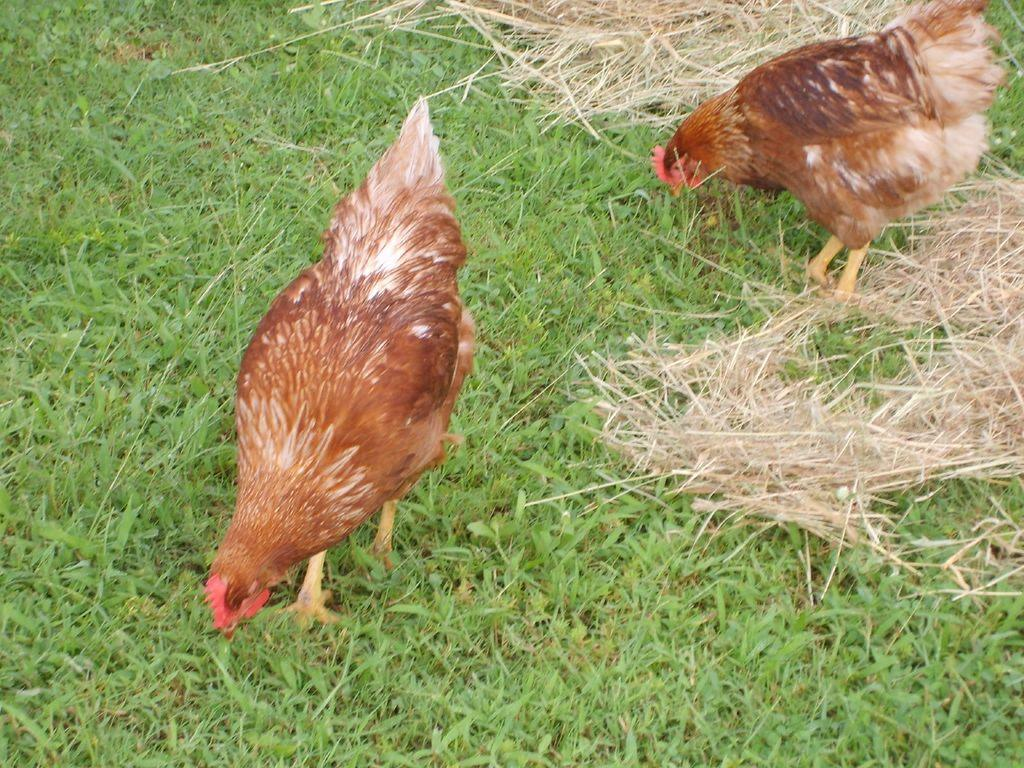How many hens are present in the image? There are two hens in the image. What color are the hens? The hens are brown in color. What are the hens doing in the image? The hens are walking on the ground. What type of vegetation can be seen in the image? There is grass visible in the image. What colors are the grass? The grass is green and brown in color. How many people are in the crowd watching the hens in the image? There is no crowd present in the image; it only features two hens walking on the grass. What is the rate at which the hens are laying eggs in the image? The image does not show the hens laying eggs, so it is not possible to determine their egg-laying rate. 